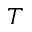Convert formula to latex. <formula><loc_0><loc_0><loc_500><loc_500>T</formula> 